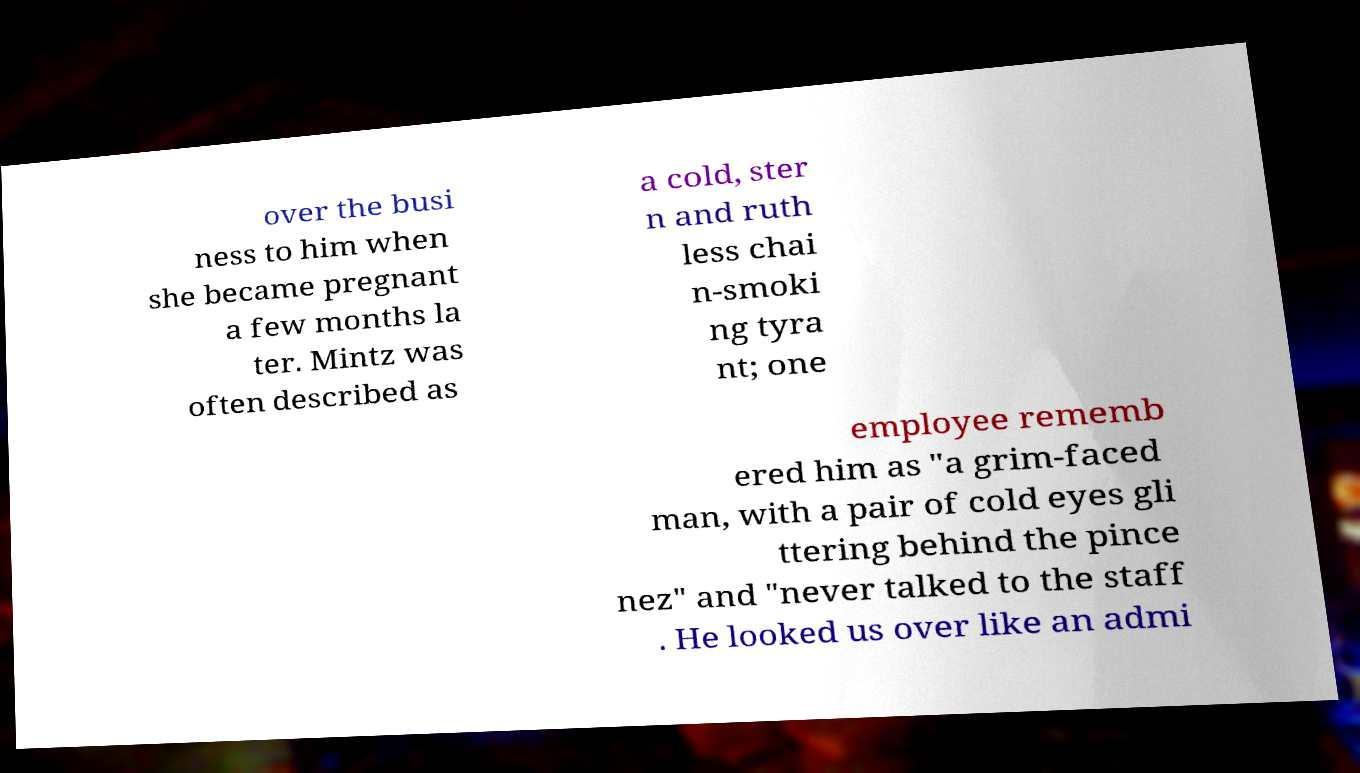Please read and relay the text visible in this image. What does it say? over the busi ness to him when she became pregnant a few months la ter. Mintz was often described as a cold, ster n and ruth less chai n-smoki ng tyra nt; one employee rememb ered him as "a grim-faced man, with a pair of cold eyes gli ttering behind the pince nez" and "never talked to the staff . He looked us over like an admi 